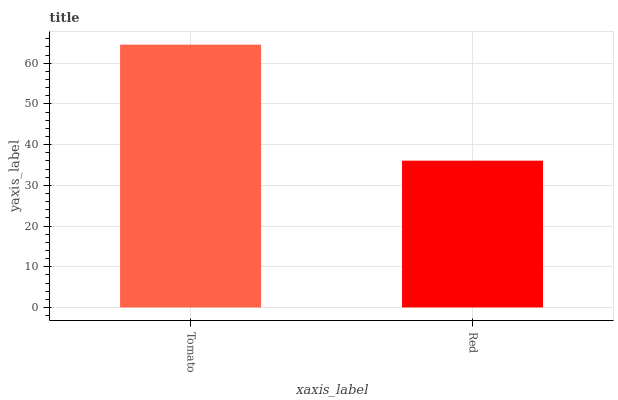Is Red the minimum?
Answer yes or no. Yes. Is Tomato the maximum?
Answer yes or no. Yes. Is Red the maximum?
Answer yes or no. No. Is Tomato greater than Red?
Answer yes or no. Yes. Is Red less than Tomato?
Answer yes or no. Yes. Is Red greater than Tomato?
Answer yes or no. No. Is Tomato less than Red?
Answer yes or no. No. Is Tomato the high median?
Answer yes or no. Yes. Is Red the low median?
Answer yes or no. Yes. Is Red the high median?
Answer yes or no. No. Is Tomato the low median?
Answer yes or no. No. 